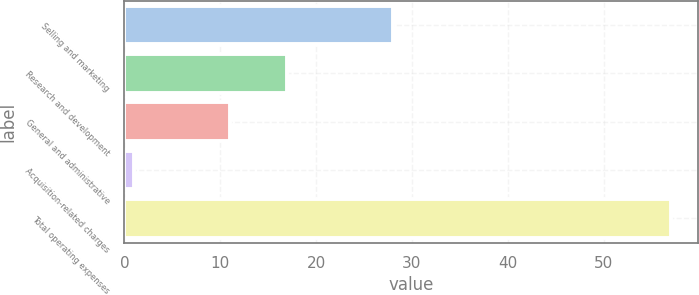<chart> <loc_0><loc_0><loc_500><loc_500><bar_chart><fcel>Selling and marketing<fcel>Research and development<fcel>General and administrative<fcel>Acquisition-related charges<fcel>Total operating expenses<nl><fcel>28<fcel>17<fcel>11<fcel>1<fcel>57<nl></chart> 